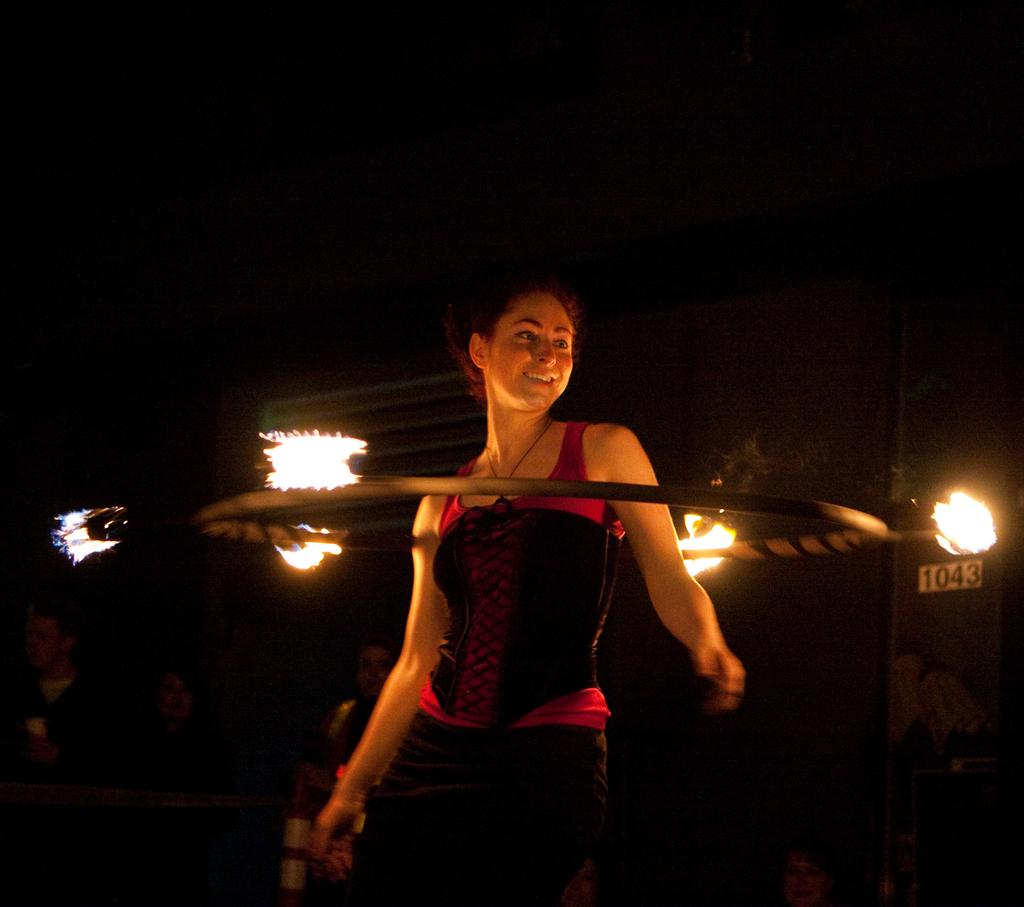Who is the main subject in the image? There is a girl in the image. What is the girl doing in the image? The girl is dancing. What can be seen in the background of the image? The background of the image is dark. What is the purpose of the fire ring in the image? The fire ring's purpose is not specified in the facts, but it could be used for a bonfire or a campfire. Can you tell me how many people are touching the girl's back in the image? There is no mention of anyone touching the girl's back in the image, so we cannot determine the number of people involved. 